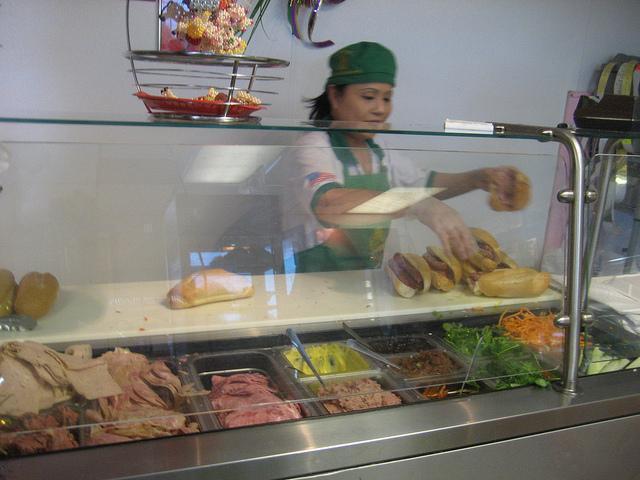What sort of specialty business is this?
Choose the right answer from the provided options to respond to the question.
Options: Philly cheesesteak, fried chicken, pizza hut, sandwich shop. Sandwich shop. 